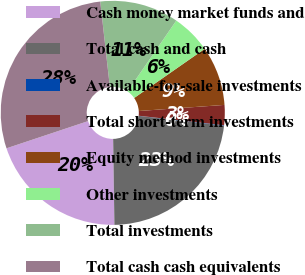Convert chart to OTSL. <chart><loc_0><loc_0><loc_500><loc_500><pie_chart><fcel>Cash money market funds and<fcel>Total cash and cash<fcel>Available-for-sale investments<fcel>Total short-term investments<fcel>Equity method investments<fcel>Other investments<fcel>Total investments<fcel>Total cash cash equivalents<nl><fcel>20.11%<fcel>22.93%<fcel>0.07%<fcel>2.9%<fcel>8.55%<fcel>5.72%<fcel>11.38%<fcel>28.34%<nl></chart> 